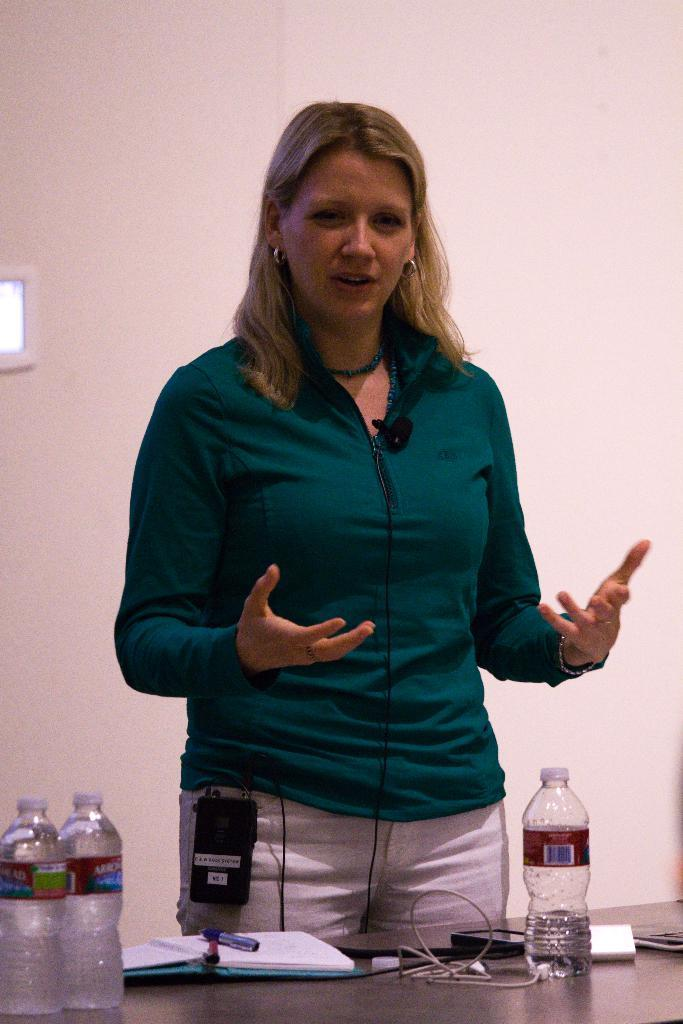What is the main subject of the image? There is a woman standing in the center of the image. What is in front of the woman? There is a table in front of the woman. What items can be seen on the table? There is a book, water bottles, a connector, a phone, and papers on the table. What is visible in the background of the image? There is a wall in the background of the image. What type of flesh can be seen on the table in the image? There is no flesh present on the table in the image. What kind of popcorn is being served on the table in the image? There is no popcorn present on the table in the image. 